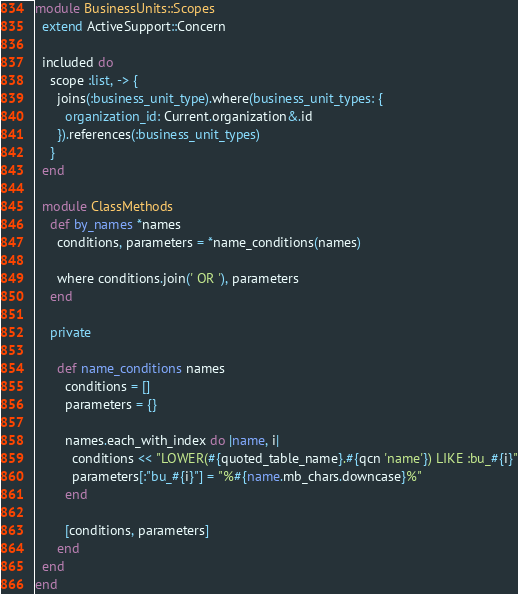Convert code to text. <code><loc_0><loc_0><loc_500><loc_500><_Ruby_>module BusinessUnits::Scopes
  extend ActiveSupport::Concern

  included do
    scope :list, -> {
      joins(:business_unit_type).where(business_unit_types: {
        organization_id: Current.organization&.id
      }).references(:business_unit_types)
    }
  end

  module ClassMethods
    def by_names *names
      conditions, parameters = *name_conditions(names)

      where conditions.join(' OR '), parameters
    end

    private

      def name_conditions names
        conditions = []
        parameters = {}

        names.each_with_index do |name, i|
          conditions << "LOWER(#{quoted_table_name}.#{qcn 'name'}) LIKE :bu_#{i}"
          parameters[:"bu_#{i}"] = "%#{name.mb_chars.downcase}%"
        end

        [conditions, parameters]
      end
  end
end
</code> 